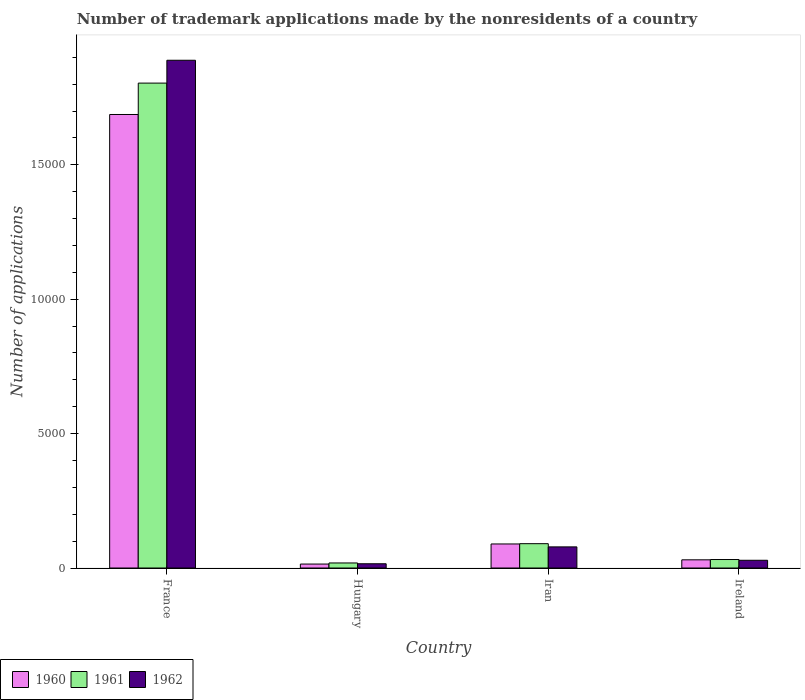How many different coloured bars are there?
Your answer should be compact. 3. Are the number of bars on each tick of the X-axis equal?
Make the answer very short. Yes. How many bars are there on the 4th tick from the left?
Provide a short and direct response. 3. How many bars are there on the 2nd tick from the right?
Your answer should be compact. 3. What is the label of the 2nd group of bars from the left?
Give a very brief answer. Hungary. In how many cases, is the number of bars for a given country not equal to the number of legend labels?
Offer a terse response. 0. What is the number of trademark applications made by the nonresidents in 1961 in France?
Offer a very short reply. 1.80e+04. Across all countries, what is the maximum number of trademark applications made by the nonresidents in 1961?
Your response must be concise. 1.80e+04. Across all countries, what is the minimum number of trademark applications made by the nonresidents in 1962?
Keep it short and to the point. 158. In which country was the number of trademark applications made by the nonresidents in 1960 minimum?
Ensure brevity in your answer.  Hungary. What is the total number of trademark applications made by the nonresidents in 1962 in the graph?
Give a very brief answer. 2.01e+04. What is the difference between the number of trademark applications made by the nonresidents in 1960 in France and that in Ireland?
Make the answer very short. 1.66e+04. What is the difference between the number of trademark applications made by the nonresidents in 1962 in Ireland and the number of trademark applications made by the nonresidents in 1960 in Iran?
Provide a succinct answer. -607. What is the average number of trademark applications made by the nonresidents in 1961 per country?
Your response must be concise. 4862.75. In how many countries, is the number of trademark applications made by the nonresidents in 1962 greater than 17000?
Ensure brevity in your answer.  1. What is the ratio of the number of trademark applications made by the nonresidents in 1960 in France to that in Hungary?
Offer a terse response. 114.79. Is the number of trademark applications made by the nonresidents in 1961 in France less than that in Ireland?
Your response must be concise. No. What is the difference between the highest and the second highest number of trademark applications made by the nonresidents in 1961?
Give a very brief answer. -1.71e+04. What is the difference between the highest and the lowest number of trademark applications made by the nonresidents in 1960?
Your answer should be very brief. 1.67e+04. Is the sum of the number of trademark applications made by the nonresidents in 1960 in France and Hungary greater than the maximum number of trademark applications made by the nonresidents in 1961 across all countries?
Your response must be concise. No. What does the 3rd bar from the left in Iran represents?
Give a very brief answer. 1962. Is it the case that in every country, the sum of the number of trademark applications made by the nonresidents in 1960 and number of trademark applications made by the nonresidents in 1961 is greater than the number of trademark applications made by the nonresidents in 1962?
Provide a short and direct response. Yes. How many bars are there?
Your answer should be compact. 12. How many countries are there in the graph?
Your answer should be very brief. 4. Are the values on the major ticks of Y-axis written in scientific E-notation?
Your answer should be very brief. No. Does the graph contain grids?
Offer a very short reply. No. What is the title of the graph?
Give a very brief answer. Number of trademark applications made by the nonresidents of a country. Does "1963" appear as one of the legend labels in the graph?
Give a very brief answer. No. What is the label or title of the Y-axis?
Keep it short and to the point. Number of applications. What is the Number of applications in 1960 in France?
Your response must be concise. 1.69e+04. What is the Number of applications in 1961 in France?
Provide a short and direct response. 1.80e+04. What is the Number of applications of 1962 in France?
Your answer should be compact. 1.89e+04. What is the Number of applications in 1960 in Hungary?
Offer a very short reply. 147. What is the Number of applications of 1961 in Hungary?
Your response must be concise. 188. What is the Number of applications of 1962 in Hungary?
Your response must be concise. 158. What is the Number of applications of 1960 in Iran?
Your response must be concise. 895. What is the Number of applications in 1961 in Iran?
Your response must be concise. 905. What is the Number of applications of 1962 in Iran?
Offer a very short reply. 786. What is the Number of applications of 1960 in Ireland?
Your answer should be very brief. 305. What is the Number of applications of 1961 in Ireland?
Make the answer very short. 316. What is the Number of applications in 1962 in Ireland?
Keep it short and to the point. 288. Across all countries, what is the maximum Number of applications of 1960?
Give a very brief answer. 1.69e+04. Across all countries, what is the maximum Number of applications of 1961?
Give a very brief answer. 1.80e+04. Across all countries, what is the maximum Number of applications of 1962?
Your answer should be very brief. 1.89e+04. Across all countries, what is the minimum Number of applications of 1960?
Give a very brief answer. 147. Across all countries, what is the minimum Number of applications of 1961?
Keep it short and to the point. 188. Across all countries, what is the minimum Number of applications in 1962?
Ensure brevity in your answer.  158. What is the total Number of applications of 1960 in the graph?
Give a very brief answer. 1.82e+04. What is the total Number of applications in 1961 in the graph?
Keep it short and to the point. 1.95e+04. What is the total Number of applications of 1962 in the graph?
Ensure brevity in your answer.  2.01e+04. What is the difference between the Number of applications of 1960 in France and that in Hungary?
Provide a succinct answer. 1.67e+04. What is the difference between the Number of applications of 1961 in France and that in Hungary?
Keep it short and to the point. 1.79e+04. What is the difference between the Number of applications in 1962 in France and that in Hungary?
Provide a short and direct response. 1.87e+04. What is the difference between the Number of applications of 1960 in France and that in Iran?
Make the answer very short. 1.60e+04. What is the difference between the Number of applications of 1961 in France and that in Iran?
Provide a short and direct response. 1.71e+04. What is the difference between the Number of applications of 1962 in France and that in Iran?
Give a very brief answer. 1.81e+04. What is the difference between the Number of applications in 1960 in France and that in Ireland?
Your answer should be compact. 1.66e+04. What is the difference between the Number of applications of 1961 in France and that in Ireland?
Your answer should be very brief. 1.77e+04. What is the difference between the Number of applications of 1962 in France and that in Ireland?
Provide a short and direct response. 1.86e+04. What is the difference between the Number of applications of 1960 in Hungary and that in Iran?
Make the answer very short. -748. What is the difference between the Number of applications in 1961 in Hungary and that in Iran?
Offer a terse response. -717. What is the difference between the Number of applications in 1962 in Hungary and that in Iran?
Offer a very short reply. -628. What is the difference between the Number of applications in 1960 in Hungary and that in Ireland?
Make the answer very short. -158. What is the difference between the Number of applications of 1961 in Hungary and that in Ireland?
Ensure brevity in your answer.  -128. What is the difference between the Number of applications in 1962 in Hungary and that in Ireland?
Provide a succinct answer. -130. What is the difference between the Number of applications in 1960 in Iran and that in Ireland?
Your answer should be very brief. 590. What is the difference between the Number of applications in 1961 in Iran and that in Ireland?
Your answer should be compact. 589. What is the difference between the Number of applications of 1962 in Iran and that in Ireland?
Provide a short and direct response. 498. What is the difference between the Number of applications of 1960 in France and the Number of applications of 1961 in Hungary?
Offer a very short reply. 1.67e+04. What is the difference between the Number of applications in 1960 in France and the Number of applications in 1962 in Hungary?
Provide a succinct answer. 1.67e+04. What is the difference between the Number of applications of 1961 in France and the Number of applications of 1962 in Hungary?
Make the answer very short. 1.79e+04. What is the difference between the Number of applications in 1960 in France and the Number of applications in 1961 in Iran?
Provide a short and direct response. 1.60e+04. What is the difference between the Number of applications of 1960 in France and the Number of applications of 1962 in Iran?
Offer a terse response. 1.61e+04. What is the difference between the Number of applications in 1961 in France and the Number of applications in 1962 in Iran?
Keep it short and to the point. 1.73e+04. What is the difference between the Number of applications in 1960 in France and the Number of applications in 1961 in Ireland?
Offer a very short reply. 1.66e+04. What is the difference between the Number of applications in 1960 in France and the Number of applications in 1962 in Ireland?
Your answer should be compact. 1.66e+04. What is the difference between the Number of applications of 1961 in France and the Number of applications of 1962 in Ireland?
Your answer should be compact. 1.78e+04. What is the difference between the Number of applications of 1960 in Hungary and the Number of applications of 1961 in Iran?
Your answer should be compact. -758. What is the difference between the Number of applications in 1960 in Hungary and the Number of applications in 1962 in Iran?
Offer a very short reply. -639. What is the difference between the Number of applications of 1961 in Hungary and the Number of applications of 1962 in Iran?
Offer a terse response. -598. What is the difference between the Number of applications in 1960 in Hungary and the Number of applications in 1961 in Ireland?
Provide a short and direct response. -169. What is the difference between the Number of applications of 1960 in Hungary and the Number of applications of 1962 in Ireland?
Your response must be concise. -141. What is the difference between the Number of applications in 1961 in Hungary and the Number of applications in 1962 in Ireland?
Your answer should be compact. -100. What is the difference between the Number of applications of 1960 in Iran and the Number of applications of 1961 in Ireland?
Keep it short and to the point. 579. What is the difference between the Number of applications of 1960 in Iran and the Number of applications of 1962 in Ireland?
Ensure brevity in your answer.  607. What is the difference between the Number of applications in 1961 in Iran and the Number of applications in 1962 in Ireland?
Give a very brief answer. 617. What is the average Number of applications in 1960 per country?
Your answer should be compact. 4555.25. What is the average Number of applications of 1961 per country?
Ensure brevity in your answer.  4862.75. What is the average Number of applications in 1962 per country?
Keep it short and to the point. 5031. What is the difference between the Number of applications of 1960 and Number of applications of 1961 in France?
Provide a succinct answer. -1168. What is the difference between the Number of applications in 1960 and Number of applications in 1962 in France?
Make the answer very short. -2018. What is the difference between the Number of applications of 1961 and Number of applications of 1962 in France?
Offer a very short reply. -850. What is the difference between the Number of applications of 1960 and Number of applications of 1961 in Hungary?
Make the answer very short. -41. What is the difference between the Number of applications of 1960 and Number of applications of 1962 in Hungary?
Make the answer very short. -11. What is the difference between the Number of applications of 1960 and Number of applications of 1962 in Iran?
Give a very brief answer. 109. What is the difference between the Number of applications in 1961 and Number of applications in 1962 in Iran?
Offer a terse response. 119. What is the difference between the Number of applications in 1960 and Number of applications in 1961 in Ireland?
Your answer should be compact. -11. What is the difference between the Number of applications of 1960 and Number of applications of 1962 in Ireland?
Make the answer very short. 17. What is the difference between the Number of applications of 1961 and Number of applications of 1962 in Ireland?
Give a very brief answer. 28. What is the ratio of the Number of applications of 1960 in France to that in Hungary?
Provide a succinct answer. 114.79. What is the ratio of the Number of applications of 1961 in France to that in Hungary?
Provide a succinct answer. 95.97. What is the ratio of the Number of applications of 1962 in France to that in Hungary?
Offer a very short reply. 119.57. What is the ratio of the Number of applications in 1960 in France to that in Iran?
Offer a very short reply. 18.85. What is the ratio of the Number of applications of 1961 in France to that in Iran?
Ensure brevity in your answer.  19.94. What is the ratio of the Number of applications of 1962 in France to that in Iran?
Offer a terse response. 24.04. What is the ratio of the Number of applications of 1960 in France to that in Ireland?
Offer a very short reply. 55.32. What is the ratio of the Number of applications of 1961 in France to that in Ireland?
Your answer should be compact. 57.09. What is the ratio of the Number of applications of 1962 in France to that in Ireland?
Your response must be concise. 65.6. What is the ratio of the Number of applications in 1960 in Hungary to that in Iran?
Your answer should be compact. 0.16. What is the ratio of the Number of applications in 1961 in Hungary to that in Iran?
Your answer should be very brief. 0.21. What is the ratio of the Number of applications in 1962 in Hungary to that in Iran?
Offer a terse response. 0.2. What is the ratio of the Number of applications of 1960 in Hungary to that in Ireland?
Give a very brief answer. 0.48. What is the ratio of the Number of applications in 1961 in Hungary to that in Ireland?
Keep it short and to the point. 0.59. What is the ratio of the Number of applications of 1962 in Hungary to that in Ireland?
Your response must be concise. 0.55. What is the ratio of the Number of applications in 1960 in Iran to that in Ireland?
Keep it short and to the point. 2.93. What is the ratio of the Number of applications in 1961 in Iran to that in Ireland?
Provide a succinct answer. 2.86. What is the ratio of the Number of applications in 1962 in Iran to that in Ireland?
Your response must be concise. 2.73. What is the difference between the highest and the second highest Number of applications in 1960?
Keep it short and to the point. 1.60e+04. What is the difference between the highest and the second highest Number of applications in 1961?
Make the answer very short. 1.71e+04. What is the difference between the highest and the second highest Number of applications in 1962?
Your response must be concise. 1.81e+04. What is the difference between the highest and the lowest Number of applications in 1960?
Provide a short and direct response. 1.67e+04. What is the difference between the highest and the lowest Number of applications of 1961?
Offer a very short reply. 1.79e+04. What is the difference between the highest and the lowest Number of applications of 1962?
Make the answer very short. 1.87e+04. 